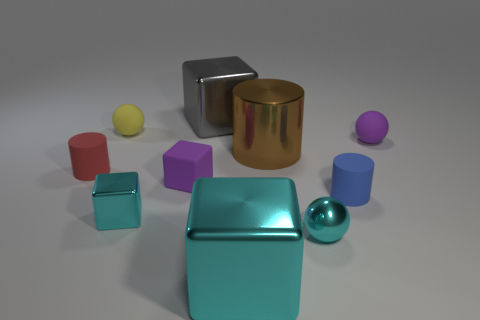Subtract all cyan blocks. How many blocks are left? 2 Subtract all purple matte spheres. How many spheres are left? 2 Subtract 2 balls. How many balls are left? 1 Add 6 yellow matte balls. How many yellow matte balls exist? 7 Subtract 1 yellow balls. How many objects are left? 9 Subtract all spheres. How many objects are left? 7 Subtract all gray cubes. Subtract all brown cylinders. How many cubes are left? 3 Subtract all brown blocks. How many green spheres are left? 0 Subtract all small brown blocks. Subtract all small purple rubber things. How many objects are left? 8 Add 7 gray objects. How many gray objects are left? 8 